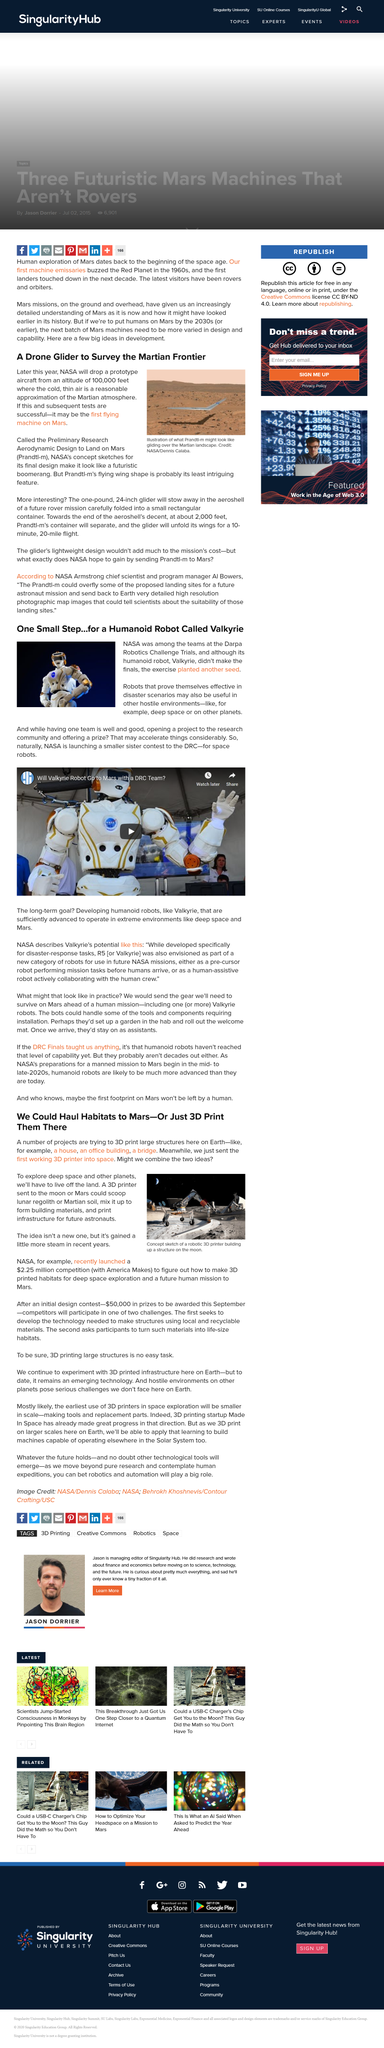List a handful of essential elements in this visual. The glider will be able to stay in-flight for a total of 10 minutes. NASA's humanoid robot did not make it to the finals. Yes, a 3D printer in space could potentially print infrastructure. At a descent altitude of 2,000 feet, the Prandtl-m's container is projected to separate from the aeroshell. We have sent one functional 3D printer into space, and it is currently the only operational 3D printer in orbit. 